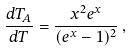<formula> <loc_0><loc_0><loc_500><loc_500>\frac { d T _ { A } } { d T } = \frac { x ^ { 2 } e ^ { x } } { ( e ^ { x } - 1 ) ^ { 2 } } \, ,</formula> 